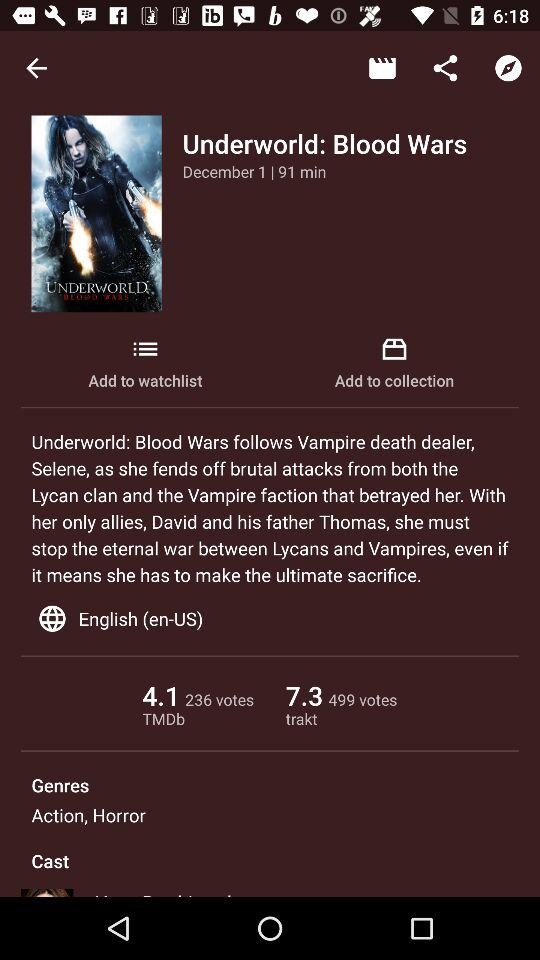What are the genres of the movie? The genres of the movie are action and horror. 